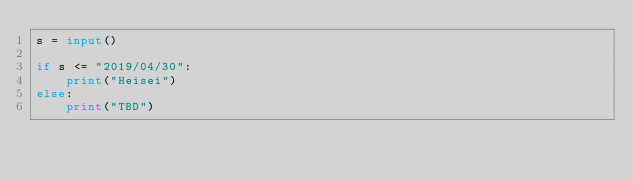Convert code to text. <code><loc_0><loc_0><loc_500><loc_500><_Python_>s = input()

if s <= "2019/04/30":
    print("Heisei")
else:
    print("TBD")

</code> 